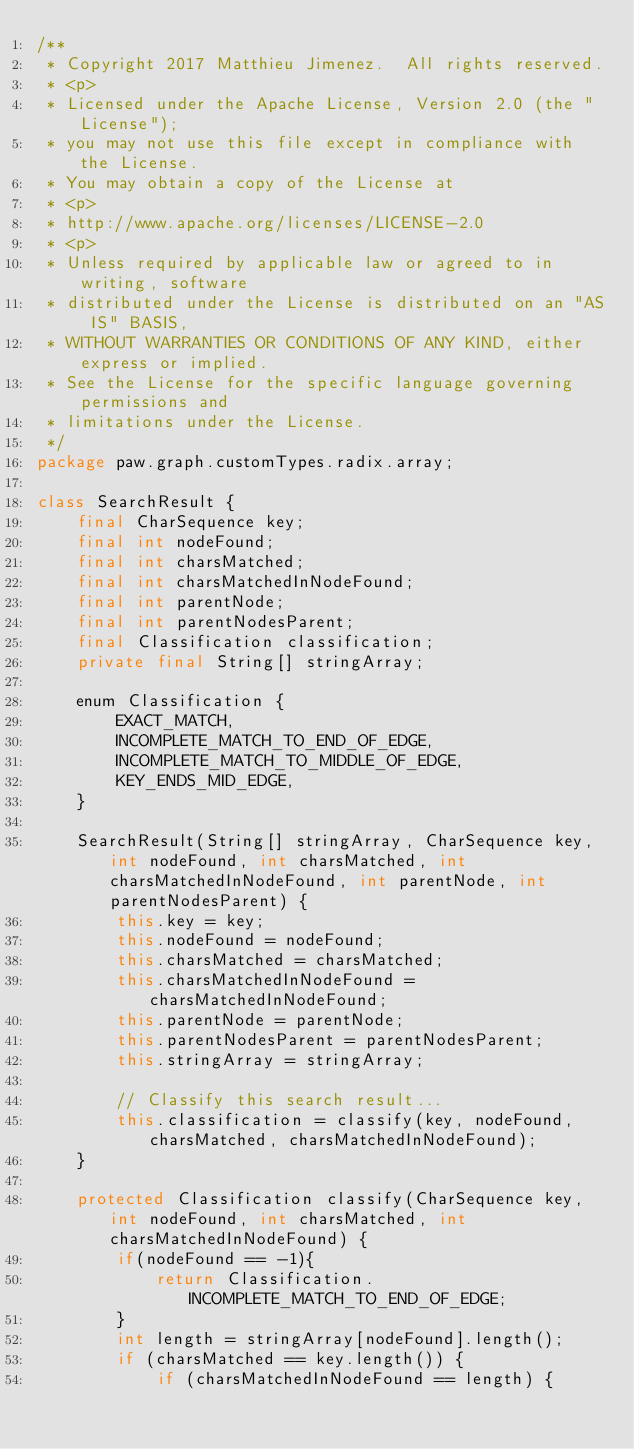<code> <loc_0><loc_0><loc_500><loc_500><_Java_>/**
 * Copyright 2017 Matthieu Jimenez.  All rights reserved.
 * <p>
 * Licensed under the Apache License, Version 2.0 (the "License");
 * you may not use this file except in compliance with the License.
 * You may obtain a copy of the License at
 * <p>
 * http://www.apache.org/licenses/LICENSE-2.0
 * <p>
 * Unless required by applicable law or agreed to in writing, software
 * distributed under the License is distributed on an "AS IS" BASIS,
 * WITHOUT WARRANTIES OR CONDITIONS OF ANY KIND, either express or implied.
 * See the License for the specific language governing permissions and
 * limitations under the License.
 */
package paw.graph.customTypes.radix.array;

class SearchResult {
    final CharSequence key;
    final int nodeFound;
    final int charsMatched;
    final int charsMatchedInNodeFound;
    final int parentNode;
    final int parentNodesParent;
    final Classification classification;
    private final String[] stringArray;

    enum Classification {
        EXACT_MATCH,
        INCOMPLETE_MATCH_TO_END_OF_EDGE,
        INCOMPLETE_MATCH_TO_MIDDLE_OF_EDGE,
        KEY_ENDS_MID_EDGE,
    }

    SearchResult(String[] stringArray, CharSequence key, int nodeFound, int charsMatched, int charsMatchedInNodeFound, int parentNode, int parentNodesParent) {
        this.key = key;
        this.nodeFound = nodeFound;
        this.charsMatched = charsMatched;
        this.charsMatchedInNodeFound = charsMatchedInNodeFound;
        this.parentNode = parentNode;
        this.parentNodesParent = parentNodesParent;
        this.stringArray = stringArray;

        // Classify this search result...
        this.classification = classify(key, nodeFound, charsMatched, charsMatchedInNodeFound);
    }

    protected Classification classify(CharSequence key, int nodeFound, int charsMatched, int charsMatchedInNodeFound) {
        if(nodeFound == -1){
            return Classification.INCOMPLETE_MATCH_TO_END_OF_EDGE;
        }
        int length = stringArray[nodeFound].length();
        if (charsMatched == key.length()) {
            if (charsMatchedInNodeFound == length) {</code> 